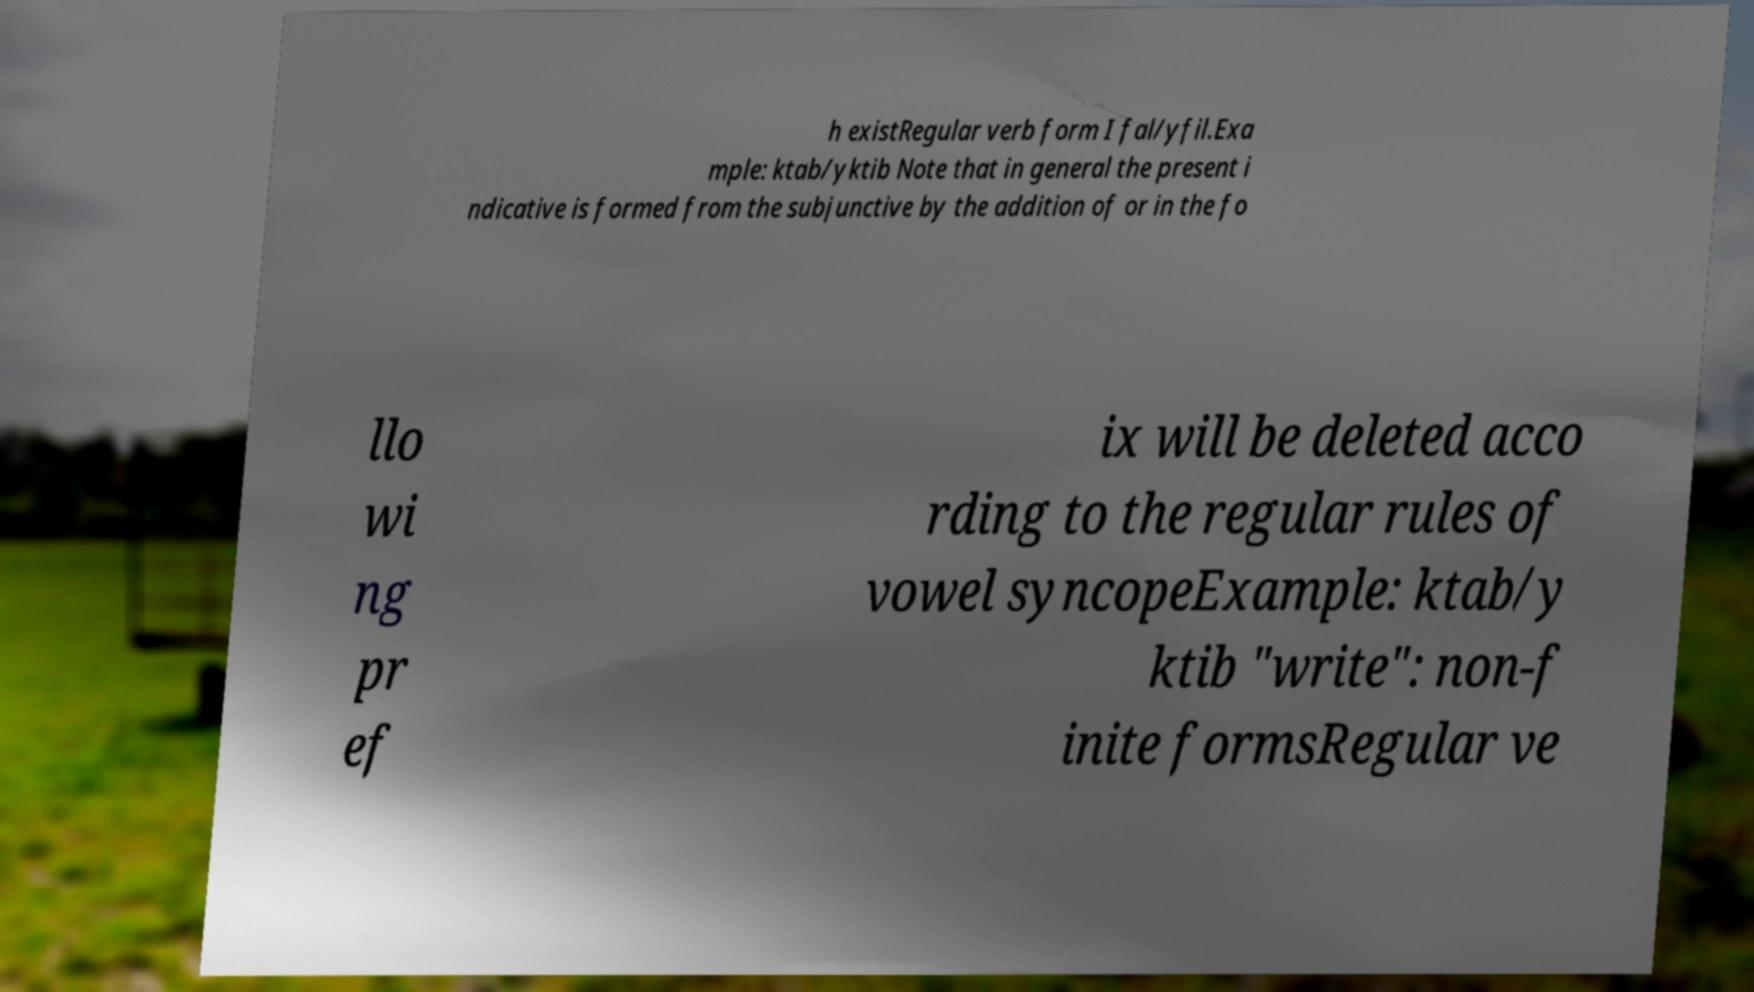Could you assist in decoding the text presented in this image and type it out clearly? h existRegular verb form I fal/yfil.Exa mple: ktab/yktib Note that in general the present i ndicative is formed from the subjunctive by the addition of or in the fo llo wi ng pr ef ix will be deleted acco rding to the regular rules of vowel syncopeExample: ktab/y ktib "write": non-f inite formsRegular ve 